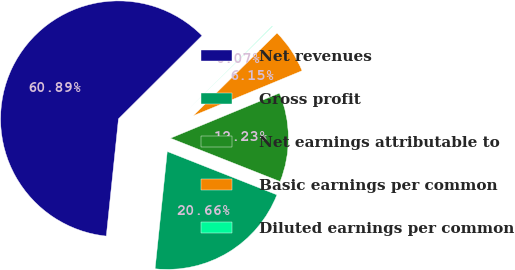Convert chart to OTSL. <chart><loc_0><loc_0><loc_500><loc_500><pie_chart><fcel>Net revenues<fcel>Gross profit<fcel>Net earnings attributable to<fcel>Basic earnings per common<fcel>Diluted earnings per common<nl><fcel>60.88%<fcel>20.66%<fcel>12.23%<fcel>6.15%<fcel>0.07%<nl></chart> 